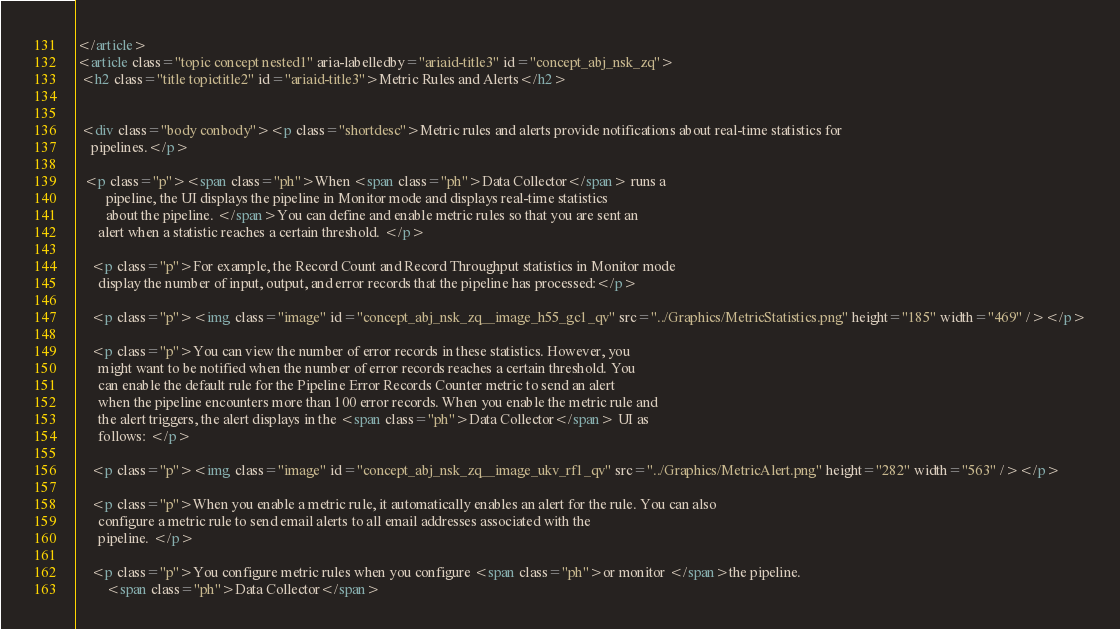Convert code to text. <code><loc_0><loc_0><loc_500><loc_500><_HTML_></article>
<article class="topic concept nested1" aria-labelledby="ariaid-title3" id="concept_abj_nsk_zq">
 <h2 class="title topictitle2" id="ariaid-title3">Metric Rules and Alerts</h2>

 
 <div class="body conbody"><p class="shortdesc">Metric rules and alerts provide notifications about real-time statistics for
    pipelines.</p>

  <p class="p"><span class="ph">When <span class="ph">Data Collector</span> runs a
        pipeline, the UI displays the pipeline in Monitor mode and displays real-time statistics
        about the pipeline. </span>You can define and enable metric rules so that you are sent an
      alert when a statistic reaches a certain threshold. </p>

    <p class="p">For example, the Record Count and Record Throughput statistics in Monitor mode
      display the number of input, output, and error records that the pipeline has processed:</p>

    <p class="p"><img class="image" id="concept_abj_nsk_zq__image_h55_gc1_qv" src="../Graphics/MetricStatistics.png" height="185" width="469" /></p>

    <p class="p">You can view the number of error records in these statistics. However, you
      might want to be notified when the number of error records reaches a certain threshold. You
      can enable the default rule for the Pipeline Error Records Counter metric to send an alert
      when the pipeline encounters more than 100 error records. When you enable the metric rule and
      the alert triggers, the alert displays in the <span class="ph">Data Collector</span> UI as
      follows: </p>

    <p class="p"><img class="image" id="concept_abj_nsk_zq__image_ukv_rf1_qv" src="../Graphics/MetricAlert.png" height="282" width="563" /></p>

    <p class="p">When you enable a metric rule, it automatically enables an alert for the rule. You can also
      configure a metric rule to send email alerts to all email addresses associated with the
      pipeline. </p>

    <p class="p">You configure metric rules when you configure <span class="ph">or monitor </span>the pipeline.
        <span class="ph">Data Collector</span></code> 